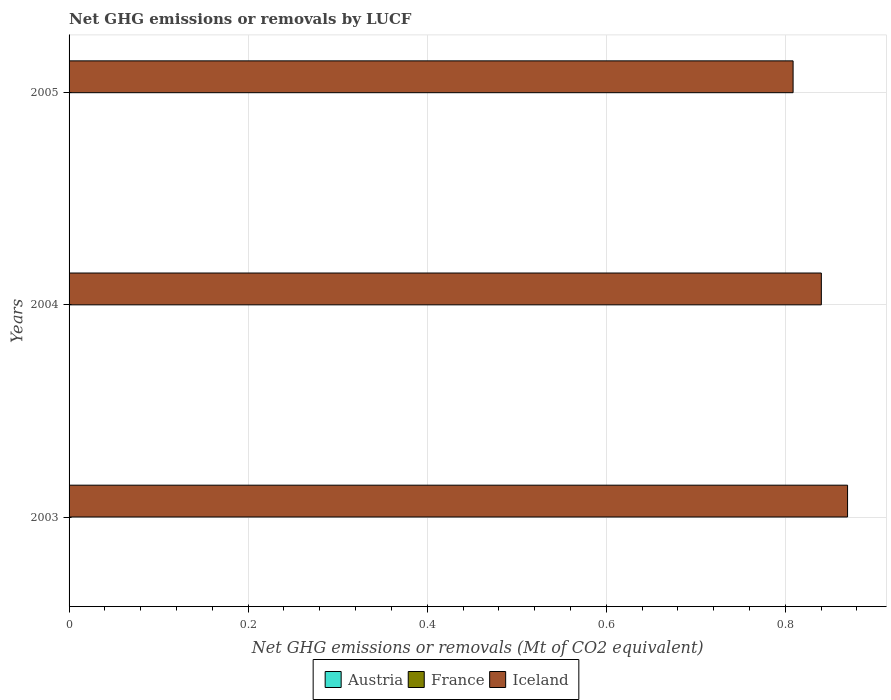How many different coloured bars are there?
Offer a very short reply. 1. Are the number of bars per tick equal to the number of legend labels?
Offer a very short reply. No. How many bars are there on the 1st tick from the top?
Your answer should be compact. 1. How many bars are there on the 2nd tick from the bottom?
Offer a very short reply. 1. What is the label of the 3rd group of bars from the top?
Your answer should be compact. 2003. In how many cases, is the number of bars for a given year not equal to the number of legend labels?
Offer a terse response. 3. What is the net GHG emissions or removals by LUCF in France in 2003?
Give a very brief answer. 0. Across all years, what is the maximum net GHG emissions or removals by LUCF in Iceland?
Ensure brevity in your answer.  0.87. What is the difference between the net GHG emissions or removals by LUCF in Iceland in 2003 and that in 2004?
Ensure brevity in your answer.  0.03. What is the difference between the net GHG emissions or removals by LUCF in Austria in 2005 and the net GHG emissions or removals by LUCF in Iceland in 2003?
Give a very brief answer. -0.87. What is the ratio of the net GHG emissions or removals by LUCF in Iceland in 2003 to that in 2005?
Ensure brevity in your answer.  1.08. What is the difference between the highest and the second highest net GHG emissions or removals by LUCF in Iceland?
Your answer should be very brief. 0.03. What is the difference between the highest and the lowest net GHG emissions or removals by LUCF in Iceland?
Make the answer very short. 0.06. Is the sum of the net GHG emissions or removals by LUCF in Iceland in 2004 and 2005 greater than the maximum net GHG emissions or removals by LUCF in France across all years?
Give a very brief answer. Yes. Are all the bars in the graph horizontal?
Give a very brief answer. Yes. How many years are there in the graph?
Keep it short and to the point. 3. Are the values on the major ticks of X-axis written in scientific E-notation?
Your answer should be compact. No. Does the graph contain any zero values?
Keep it short and to the point. Yes. Where does the legend appear in the graph?
Your response must be concise. Bottom center. How many legend labels are there?
Offer a terse response. 3. What is the title of the graph?
Provide a succinct answer. Net GHG emissions or removals by LUCF. Does "Dominican Republic" appear as one of the legend labels in the graph?
Your answer should be very brief. No. What is the label or title of the X-axis?
Your answer should be very brief. Net GHG emissions or removals (Mt of CO2 equivalent). What is the label or title of the Y-axis?
Offer a terse response. Years. What is the Net GHG emissions or removals (Mt of CO2 equivalent) of Austria in 2003?
Your response must be concise. 0. What is the Net GHG emissions or removals (Mt of CO2 equivalent) in France in 2003?
Keep it short and to the point. 0. What is the Net GHG emissions or removals (Mt of CO2 equivalent) of Iceland in 2003?
Offer a very short reply. 0.87. What is the Net GHG emissions or removals (Mt of CO2 equivalent) in France in 2004?
Offer a terse response. 0. What is the Net GHG emissions or removals (Mt of CO2 equivalent) in Iceland in 2004?
Provide a short and direct response. 0.84. What is the Net GHG emissions or removals (Mt of CO2 equivalent) in France in 2005?
Your answer should be compact. 0. What is the Net GHG emissions or removals (Mt of CO2 equivalent) of Iceland in 2005?
Offer a very short reply. 0.81. Across all years, what is the maximum Net GHG emissions or removals (Mt of CO2 equivalent) of Iceland?
Provide a short and direct response. 0.87. Across all years, what is the minimum Net GHG emissions or removals (Mt of CO2 equivalent) in Iceland?
Your answer should be compact. 0.81. What is the total Net GHG emissions or removals (Mt of CO2 equivalent) of Austria in the graph?
Your answer should be very brief. 0. What is the total Net GHG emissions or removals (Mt of CO2 equivalent) of Iceland in the graph?
Provide a succinct answer. 2.52. What is the difference between the Net GHG emissions or removals (Mt of CO2 equivalent) in Iceland in 2003 and that in 2004?
Make the answer very short. 0.03. What is the difference between the Net GHG emissions or removals (Mt of CO2 equivalent) of Iceland in 2003 and that in 2005?
Make the answer very short. 0.06. What is the difference between the Net GHG emissions or removals (Mt of CO2 equivalent) of Iceland in 2004 and that in 2005?
Ensure brevity in your answer.  0.03. What is the average Net GHG emissions or removals (Mt of CO2 equivalent) of France per year?
Your response must be concise. 0. What is the average Net GHG emissions or removals (Mt of CO2 equivalent) in Iceland per year?
Ensure brevity in your answer.  0.84. What is the ratio of the Net GHG emissions or removals (Mt of CO2 equivalent) in Iceland in 2003 to that in 2004?
Ensure brevity in your answer.  1.03. What is the ratio of the Net GHG emissions or removals (Mt of CO2 equivalent) of Iceland in 2003 to that in 2005?
Keep it short and to the point. 1.08. What is the ratio of the Net GHG emissions or removals (Mt of CO2 equivalent) of Iceland in 2004 to that in 2005?
Offer a terse response. 1.04. What is the difference between the highest and the second highest Net GHG emissions or removals (Mt of CO2 equivalent) in Iceland?
Your response must be concise. 0.03. What is the difference between the highest and the lowest Net GHG emissions or removals (Mt of CO2 equivalent) of Iceland?
Make the answer very short. 0.06. 